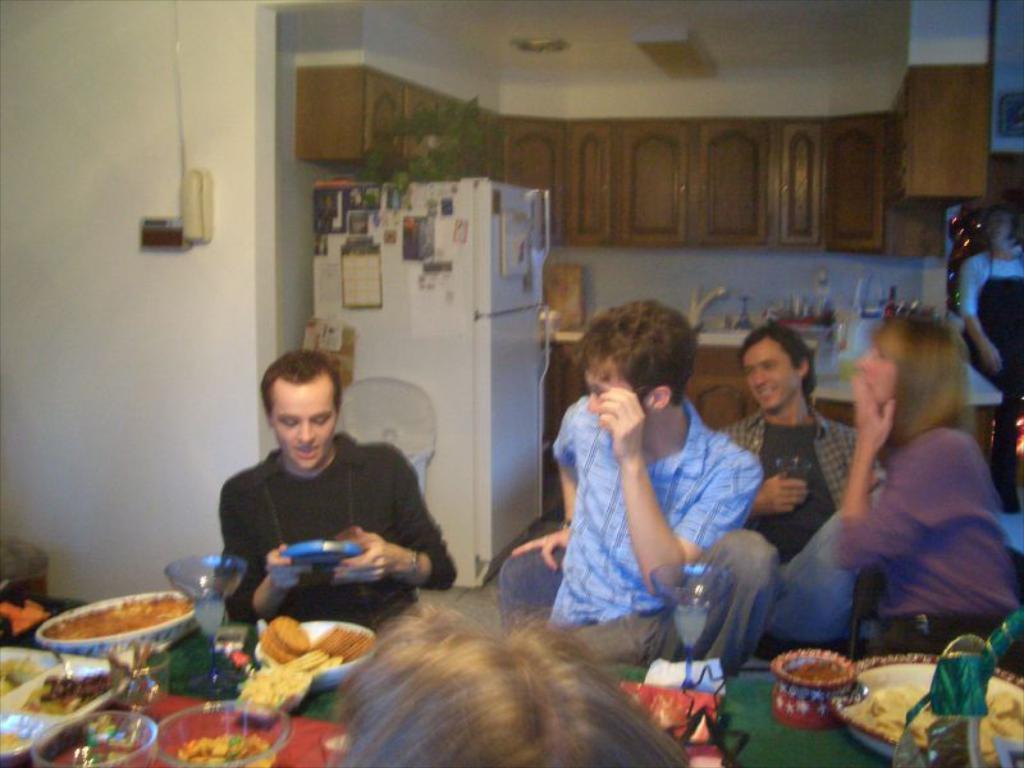Could you give a brief overview of what you see in this image? In this image there are six persons. Out of which four persons are sitting on the chair in front of the table and one person half visible and in the middle a woman is standing in front of the table, on which plates, glasses, bowls, food items and son kept. In the middle a fridge is visible and walls are white in color and shelves are there. In the middle kitchen is there. This image is taken inside a room. 